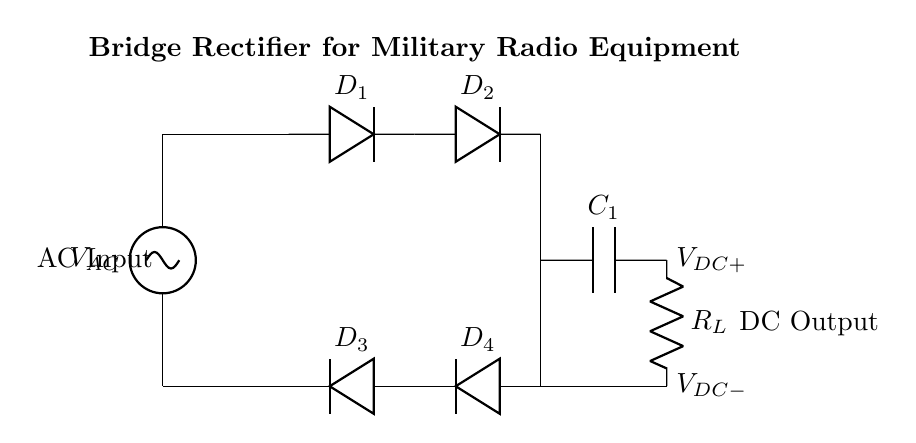What is the type of AC source used in this circuit? The circuit diagram indicates that the source is labeled as \( V_{AC} \), which designates it as an alternating current (AC) voltage source.
Answer: AC voltage source How many diodes are used in the bridge rectifier? The diagram shows a total of four diodes, labeled \( D_1, D_2, D_3, D_4 \), that are arranged in a bridge configuration.
Answer: Four What is the function of the capacitor in this circuit? Capacitor \( C_1 \) serves as a smoothing capacitor, which helps reduce voltage ripple in the output DC voltage and provides a more stable voltage supply for the load.
Answer: Smoothing Which components are located at the output of the circuit? The output consists of the capacitor \( C_1 \) and the load resistor \( R_L \), which are directly connected to each other and provide the DC output voltage.
Answer: Capacitor and load resistor What is the voltage across \( R_L \) when the rectifier is operating? In an ideal bridge rectifier circuit, the voltage across \( R_L \) can be approximated as the peak value of the AC input voltage minus the forward voltage drops of the conducting diodes, typically represented as \( V_{DC} \).
Answer: Approximately peak AC input voltage How does a bridge rectifier improve efficiency compared to a half-wave rectifier? A bridge rectifier utilizes both halves of the AC signal to produce a DC output, thereby increasing the efficiency and output voltage compared to a half-wave rectifier, which only uses one half of the AC cycle.
Answer: Higher efficiency What is the orientation of diodes \( D_3 \) and \( D_4 \) in the circuit? The diagram shows diodes \( D_3 \) and \( D_4 \) oriented in a way that they conduct during the negative half-cycle of the input AC voltage, allowing current to pass through the load in the same direction as during the positive half-cycle conducted by diodes \( D_1 \) and \( D_2 \).
Answer: Inverted (reverse) 